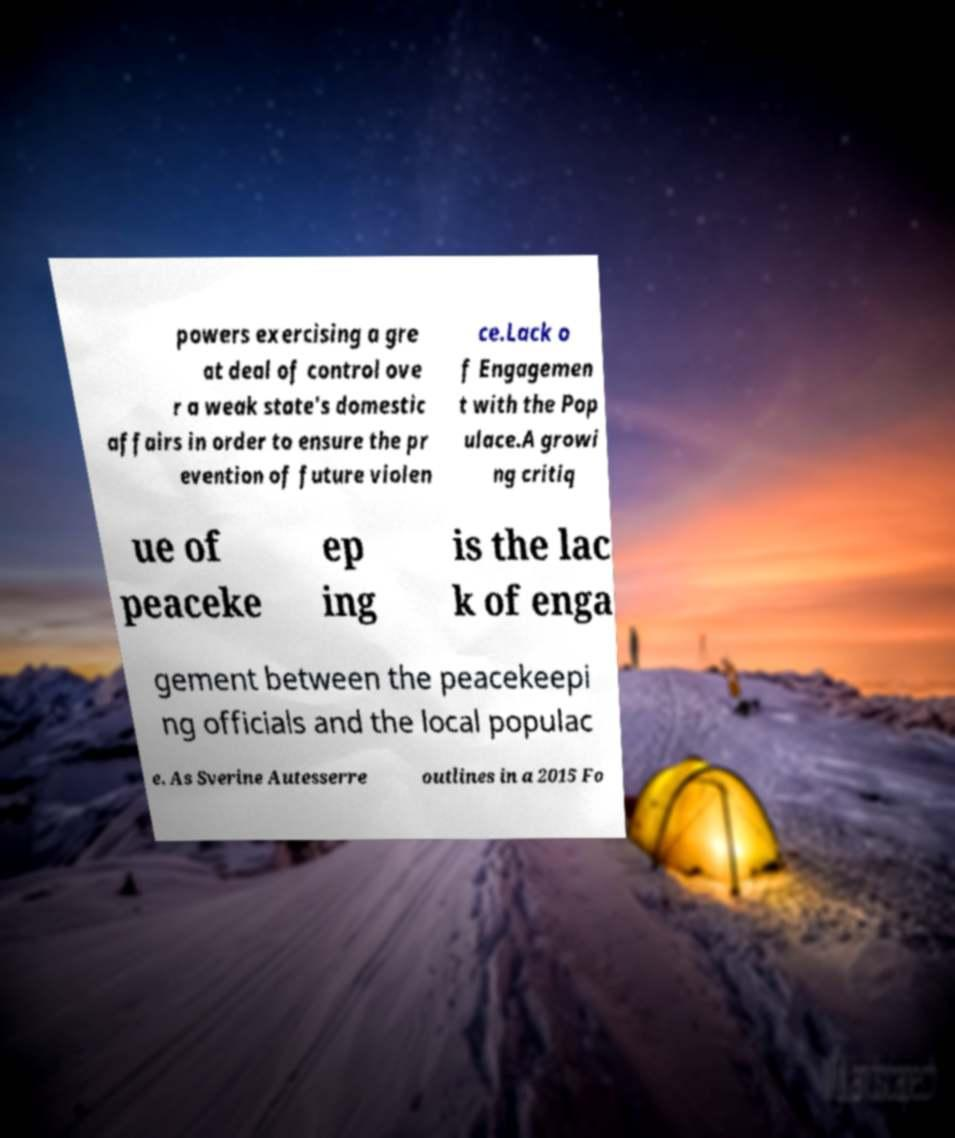Could you assist in decoding the text presented in this image and type it out clearly? powers exercising a gre at deal of control ove r a weak state's domestic affairs in order to ensure the pr evention of future violen ce.Lack o f Engagemen t with the Pop ulace.A growi ng critiq ue of peaceke ep ing is the lac k of enga gement between the peacekeepi ng officials and the local populac e. As Sverine Autesserre outlines in a 2015 Fo 